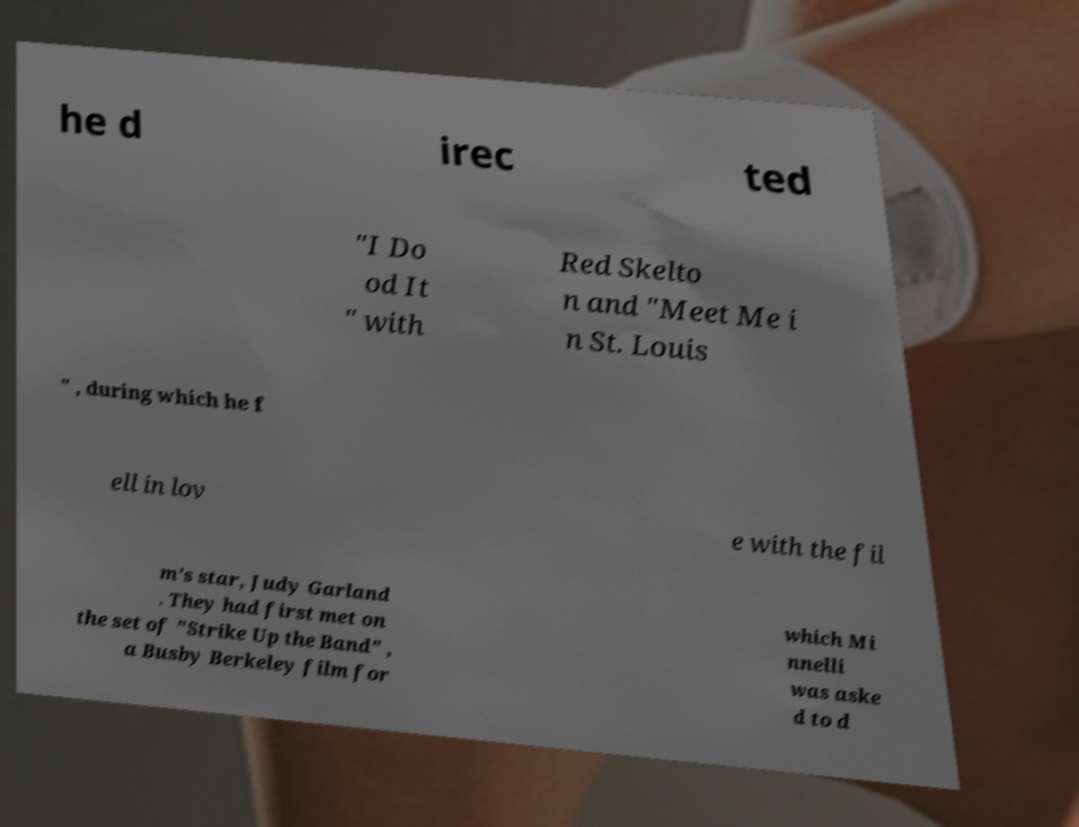Please identify and transcribe the text found in this image. he d irec ted "I Do od It " with Red Skelto n and "Meet Me i n St. Louis " , during which he f ell in lov e with the fil m's star, Judy Garland . They had first met on the set of "Strike Up the Band" , a Busby Berkeley film for which Mi nnelli was aske d to d 